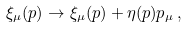Convert formula to latex. <formula><loc_0><loc_0><loc_500><loc_500>\xi _ { \mu } ( p ) \rightarrow \xi _ { \mu } ( p ) + \eta ( p ) p _ { \mu } \, ,</formula> 